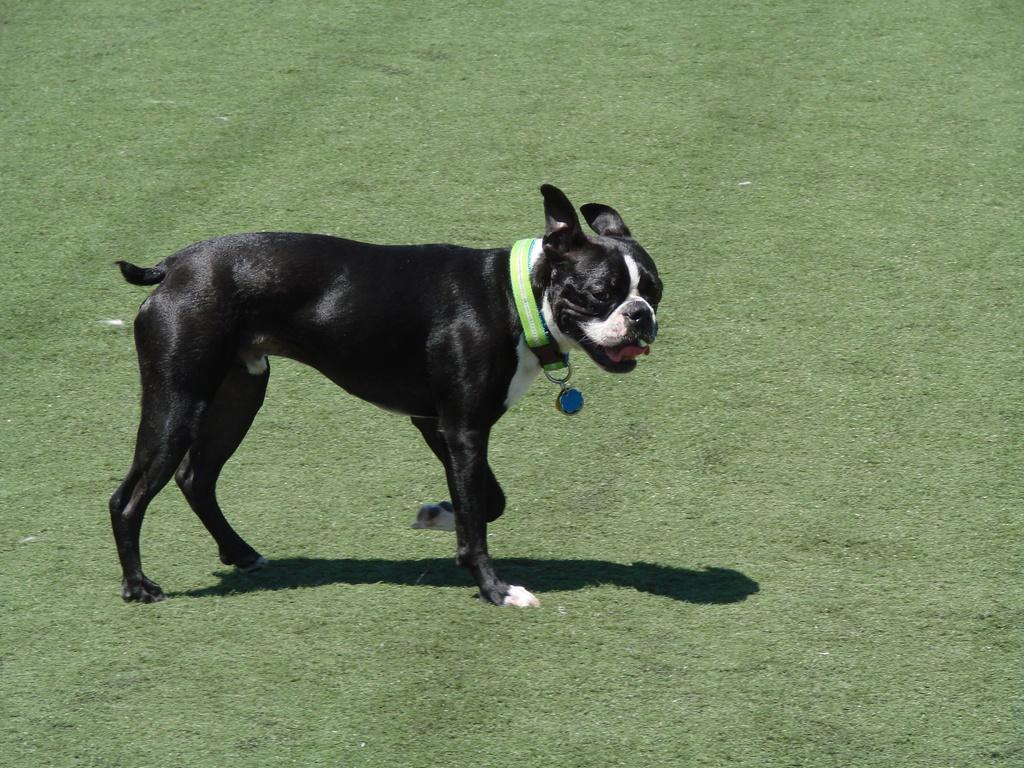Describe this image in one or two sentences. This picture is clicked outside. In the center we can see a black color dog seems to be walking on the ground. The ground is covered with the green grass. 